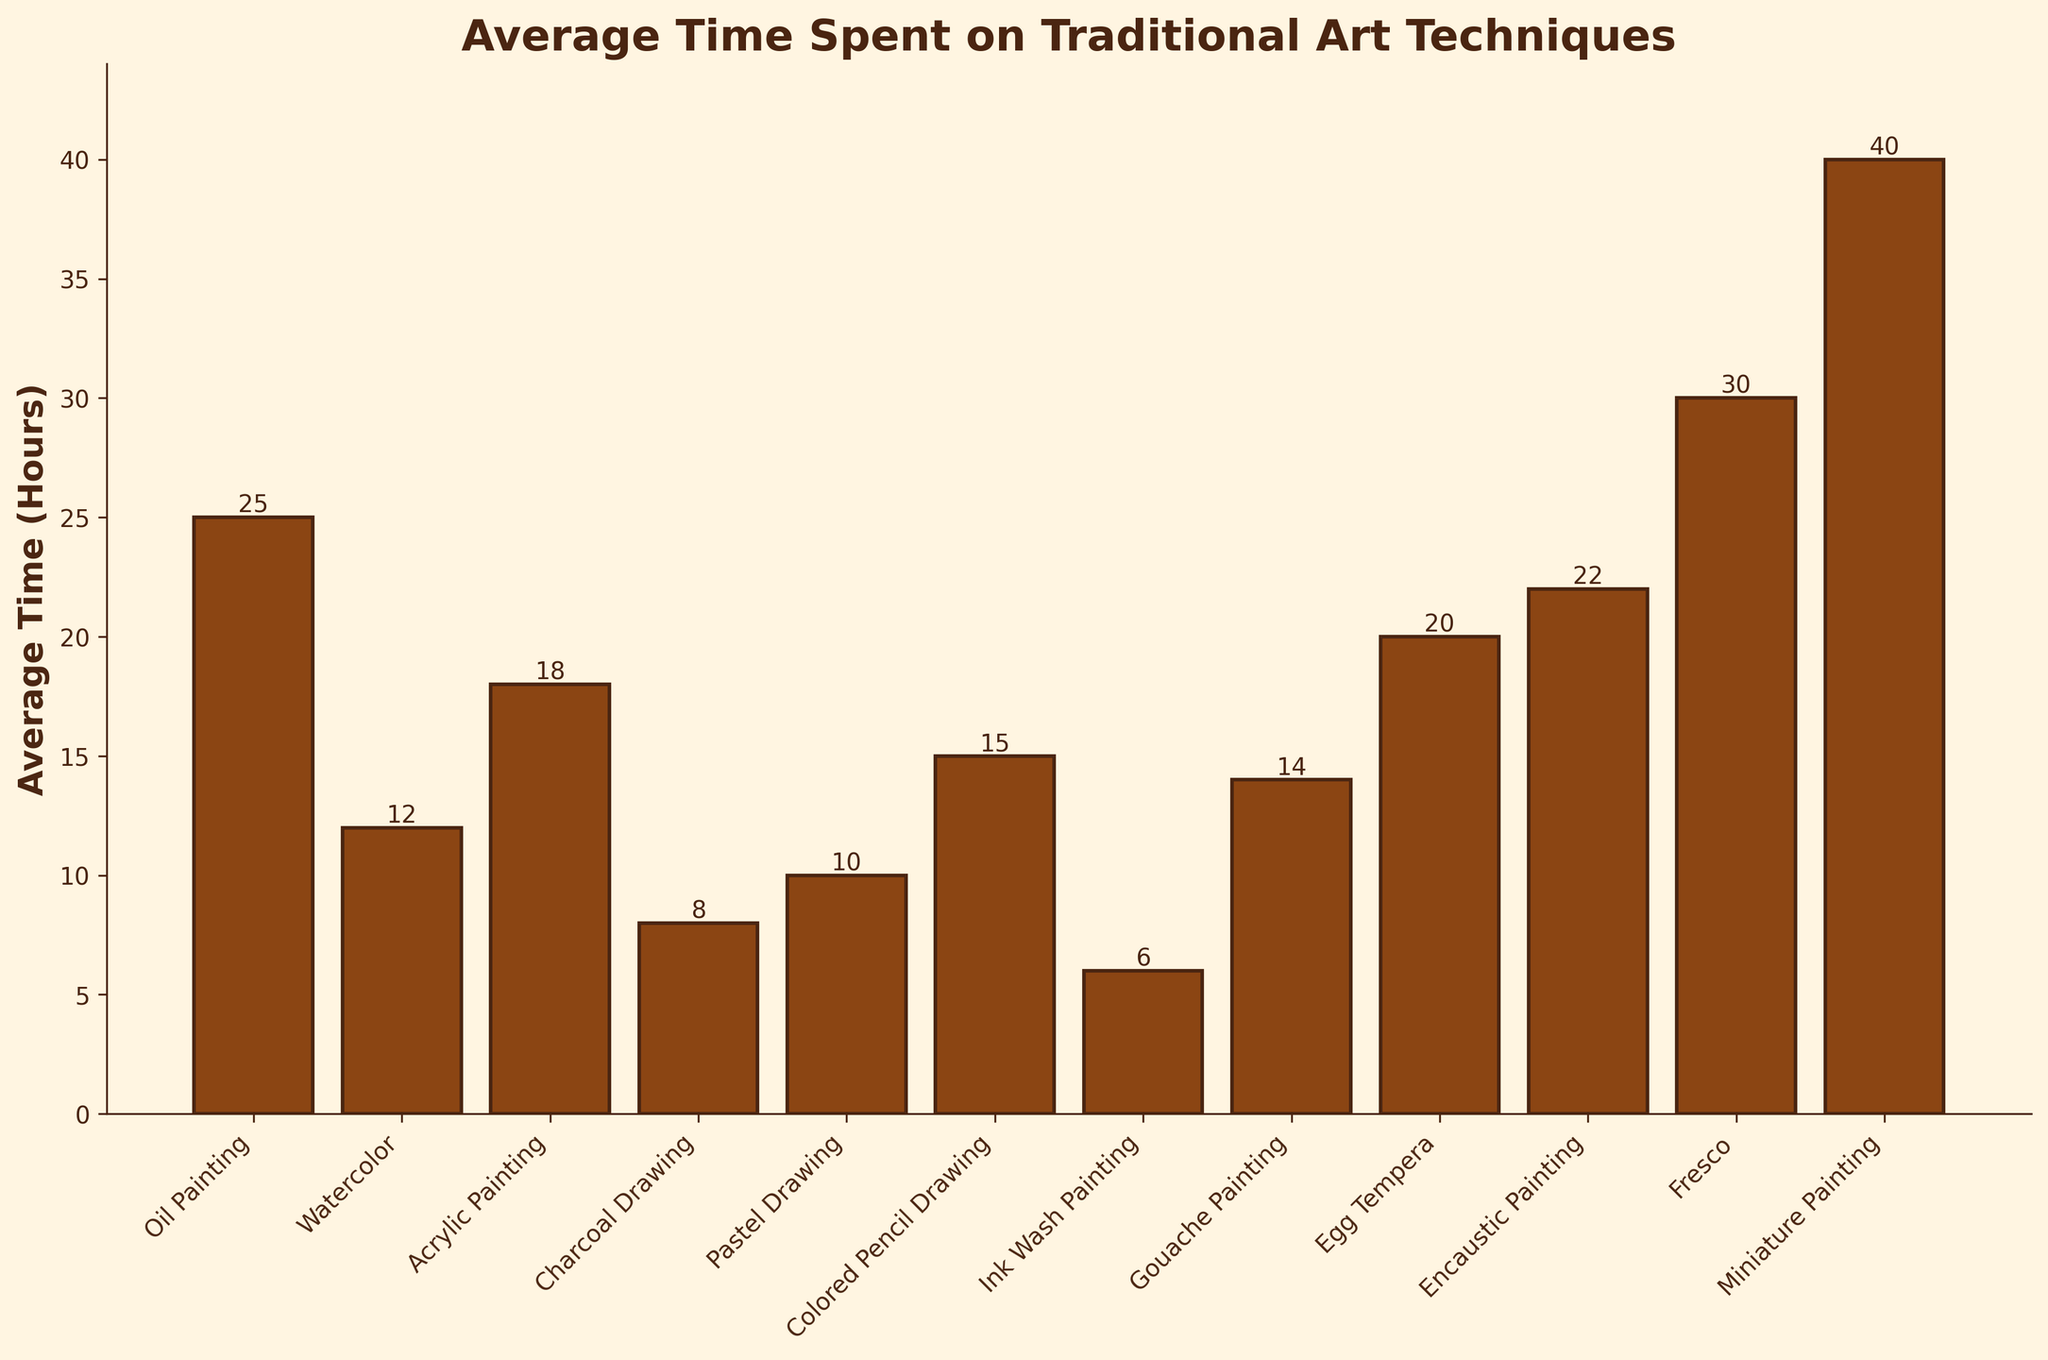what is the longest average time spent on an art technique? To determine the longest average time spent, we look for the tallest bar in the figure. The bar for Miniature Painting is the tallest, indicating it takes the longest time on average, which is 40 hours.
Answer: 40 which technique takes less time on average: Charcoal Drawing or Pastel Drawing? We compare the heights of the bars corresponding to Charcoal Drawing and Pastel Drawing. Charcoal Drawing has a lower bar (8 hours) compared to Pastel Drawing (10 hours). Thus, Charcoal Drawing takes less time.
Answer: Charcoal Drawing what is the combined average time for Watercolor and Gouache Painting? We add the average times of Watercolor (12 hours) and Gouache Painting (14 hours). So, 12 + 14 = 26 hours.
Answer: 26 which technique has the lowest average time spent? To identify the lowest average time, we find the shortest bar in the figure. The bar for Ink Wash Painting is the shortest, indicating it takes the least time on average, which is 6 hours.
Answer: 6 how much longer does Fresco take compared to Egg Tempera? We subtract the average time of Egg Tempera (20 hours) from Fresco (30 hours). So, 30 - 20 = 10 hours.
Answer: 10 what is the average time spent on three random techniques: Acrylic Painting, Colored Pencil Drawing, and Encaustic Painting? We calculate the average time by summing the times of Acrylic Painting (18 hours), Colored Pencil Drawing (15 hours), and Encaustic Painting (22 hours) and then dividing by 3. So, (18 + 15 + 22)/3 = 55/3 ≈ 18.33 hours.
Answer: 18.33 are there any techniques that take exactly 20 hours on average? By observing the heights of the bars, we find that Egg Tempera takes exactly 20 hours on average.
Answer: Egg Tempera how much less time does Ink Wash Painting take than Encaustic Painting? We subtract the average time of Ink Wash Painting (6 hours) from Encaustic Painting (22 hours). So, 22 - 6 = 16 hours.
Answer: 16 which technique takes more time: Oil Painting or Fresco? By comparing the heights of the bars, Fresco has a taller bar (30 hours) compared to Oil Painting (25 hours). Therefore, Fresco takes more time.
Answer: Fresco what is the total average time spent on all techniques combined? We sum the average times for all techniques: 25 + 12 + 18 + 8 + 10 + 15 + 6 + 14 + 20 + 22 + 30 + 40 = 220 hours.
Answer: 220 